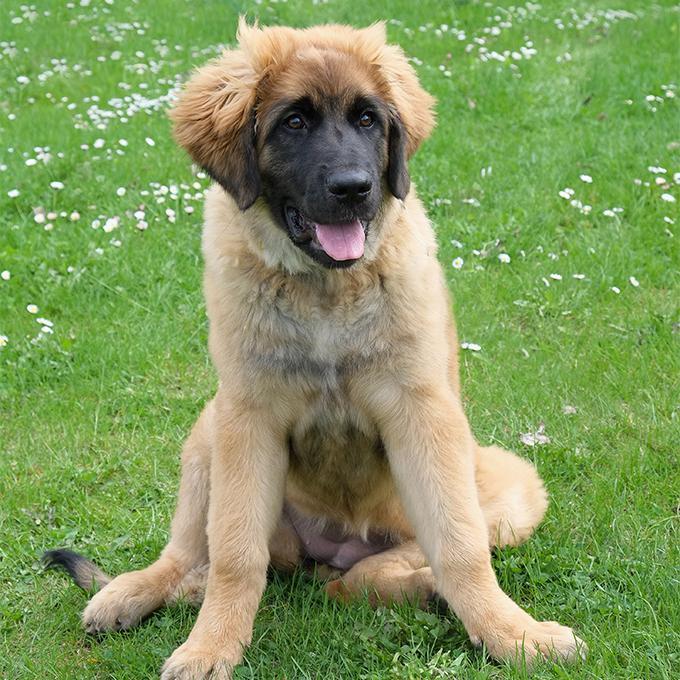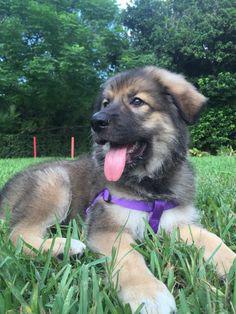The first image is the image on the left, the second image is the image on the right. Assess this claim about the two images: "A puppy is laying in the grass.". Correct or not? Answer yes or no. Yes. The first image is the image on the left, the second image is the image on the right. Evaluate the accuracy of this statement regarding the images: "One image shows a dog walking toward the camera.". Is it true? Answer yes or no. No. 